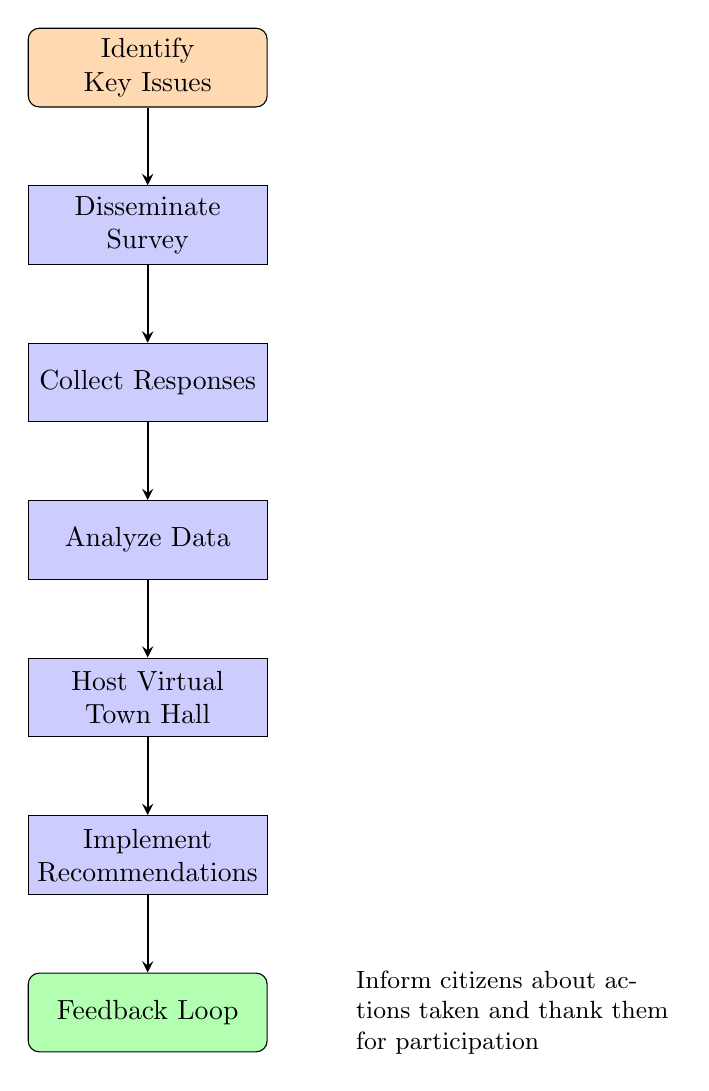What is the starting point of the process? The starting point of the flow chart is labeled "Identify Key Issues." This is the first node in the diagram, indicating the beginning of the online citizen engagement process.
Answer: Identify Key Issues How many main process nodes are there? The flow chart contains five main process nodes: "Disseminate Survey," "Collect Responses," "Analyze Data," "Host Virtual Town Hall," and "Implement Recommendations." Counting these gives a total of five.
Answer: 5 What is the last step in the engagement process? The last step in the flow chart is labeled "Feedback Loop." This indicates the termination of the flow, where citizens are informed about the actions taken based on their input.
Answer: Feedback Loop What is the relationship between "Host Virtual Town Hall" and "Implement Recommendations"? "Host Virtual Town Hall" flows directly to "Implement Recommendations," indicating that after hosting the town hall, the next step involves implementing the recommendations derived from the discussions and feedback collected.
Answer: Direct flow Which process follows "Analyze Data"? The process that follows "Analyze Data" in the flow chart is "Host Virtual Town Hall." This means after analyzing the data from the survey responses, the subsequent action is to organize a virtual meeting.
Answer: Host Virtual Town Hall What does the feedback loop involve? The feedback loop involves informing citizens about the actions taken based on their input and thanking them for their participation. This communicates the outcomes and acknowledges the engagement process's input.
Answer: Inform citizens about actions taken and thank them for participation How does "Disseminate Survey" connect to "Collect Responses"? "Disseminate Survey" connects to "Collect Responses" via a direct flow arrow, indicating that after the survey is disseminated, the next step is to collect the responses provided by participants.
Answer: Direct flow What action does "Implement Recommendations" lead to in the process? "Implement Recommendations" leads to the "Feedback Loop" in the diagram. This indicates that after recommendations have been implemented based on gathered insights, it transitions to the step of informing citizens about these actions.
Answer: Feedback Loop 